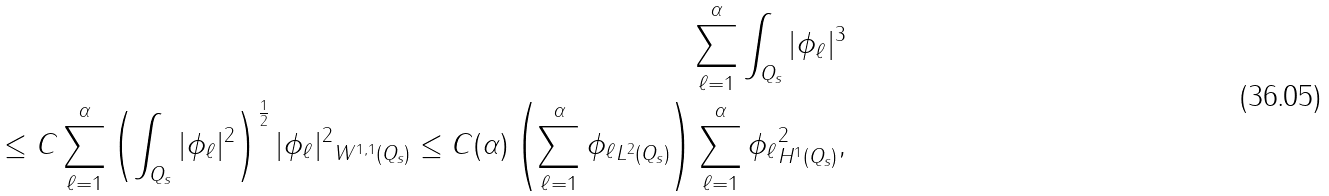Convert formula to latex. <formula><loc_0><loc_0><loc_500><loc_500>\sum _ { \ell = 1 } ^ { \alpha } \int _ { Q _ { s } } | \phi _ { \ell } | ^ { 3 } \\ \leq C \sum _ { \ell = 1 } ^ { \alpha } \left ( \int _ { Q _ { s } } | \phi _ { \ell } | ^ { 2 } \right ) ^ { \frac { 1 } { 2 } } \| | \phi _ { \ell } | ^ { 2 } \| _ { W ^ { 1 , 1 } ( Q _ { s } ) } \leq C ( \alpha ) \left ( \sum _ { \ell = 1 } ^ { \alpha } \| \phi _ { \ell } \| _ { L ^ { 2 } ( Q _ { s } ) } \right ) \sum _ { \ell = 1 } ^ { \alpha } \| \phi _ { \ell } \| _ { H ^ { 1 } ( Q _ { s } ) } ^ { 2 } , &</formula> 